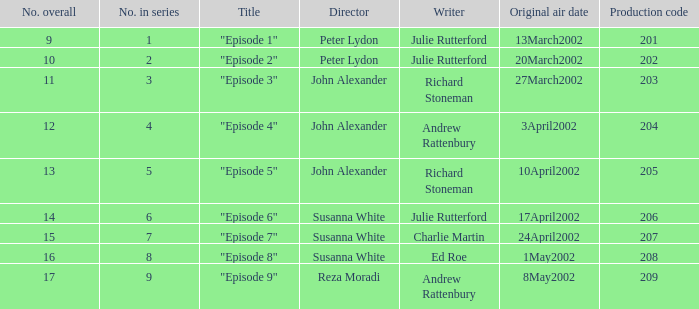With 15 as the overall number, when did it originally air? 24April2002. 